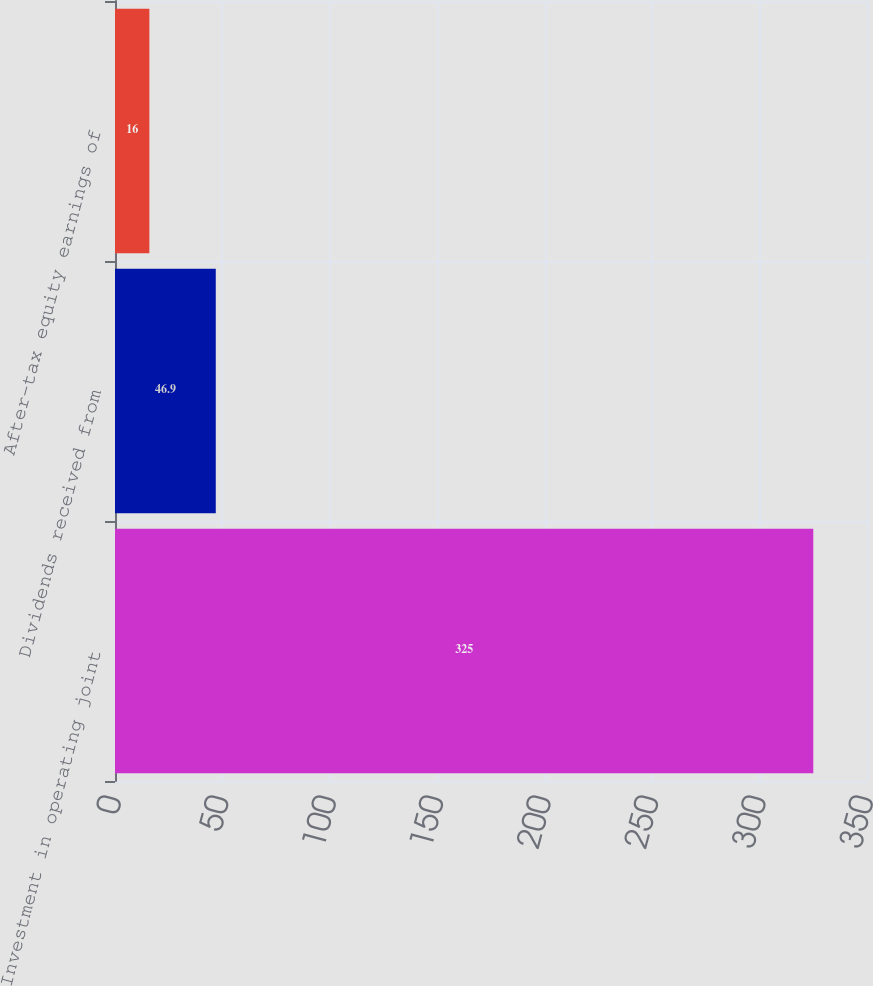<chart> <loc_0><loc_0><loc_500><loc_500><bar_chart><fcel>Investment in operating joint<fcel>Dividends received from<fcel>After-tax equity earnings of<nl><fcel>325<fcel>46.9<fcel>16<nl></chart> 